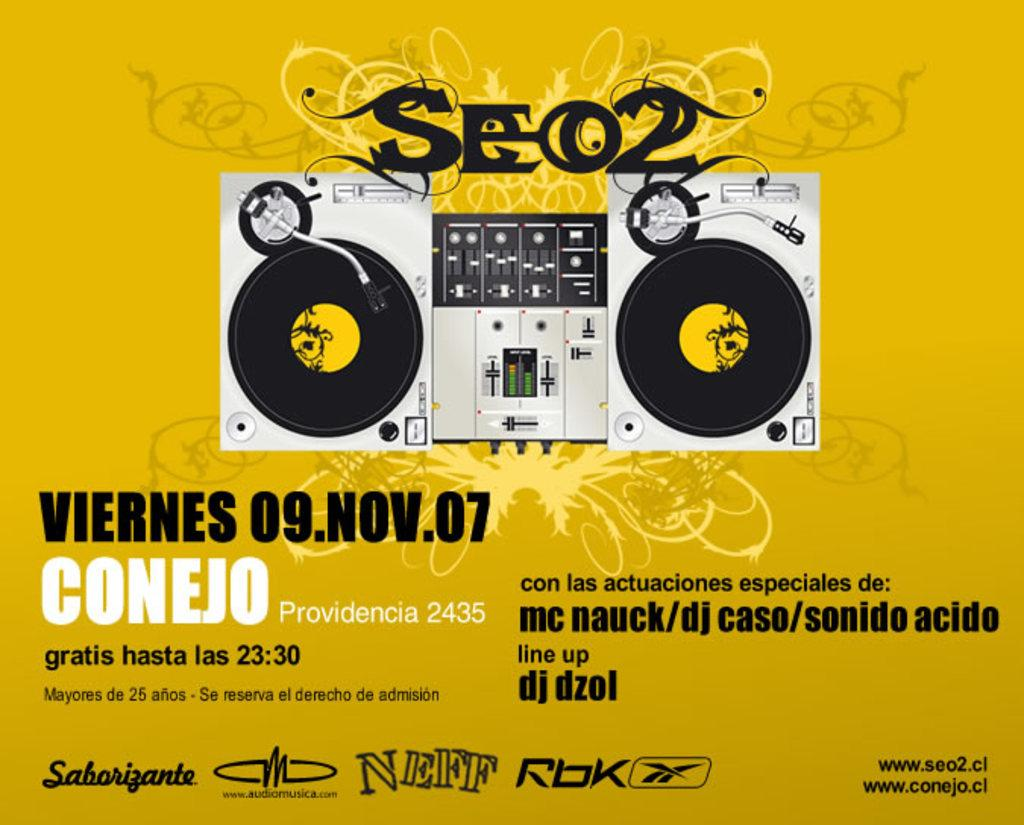Provide a one-sentence caption for the provided image. A music festival that was held on November 9, 2007 in Provedencia, Columbia is being shown on this poster. 